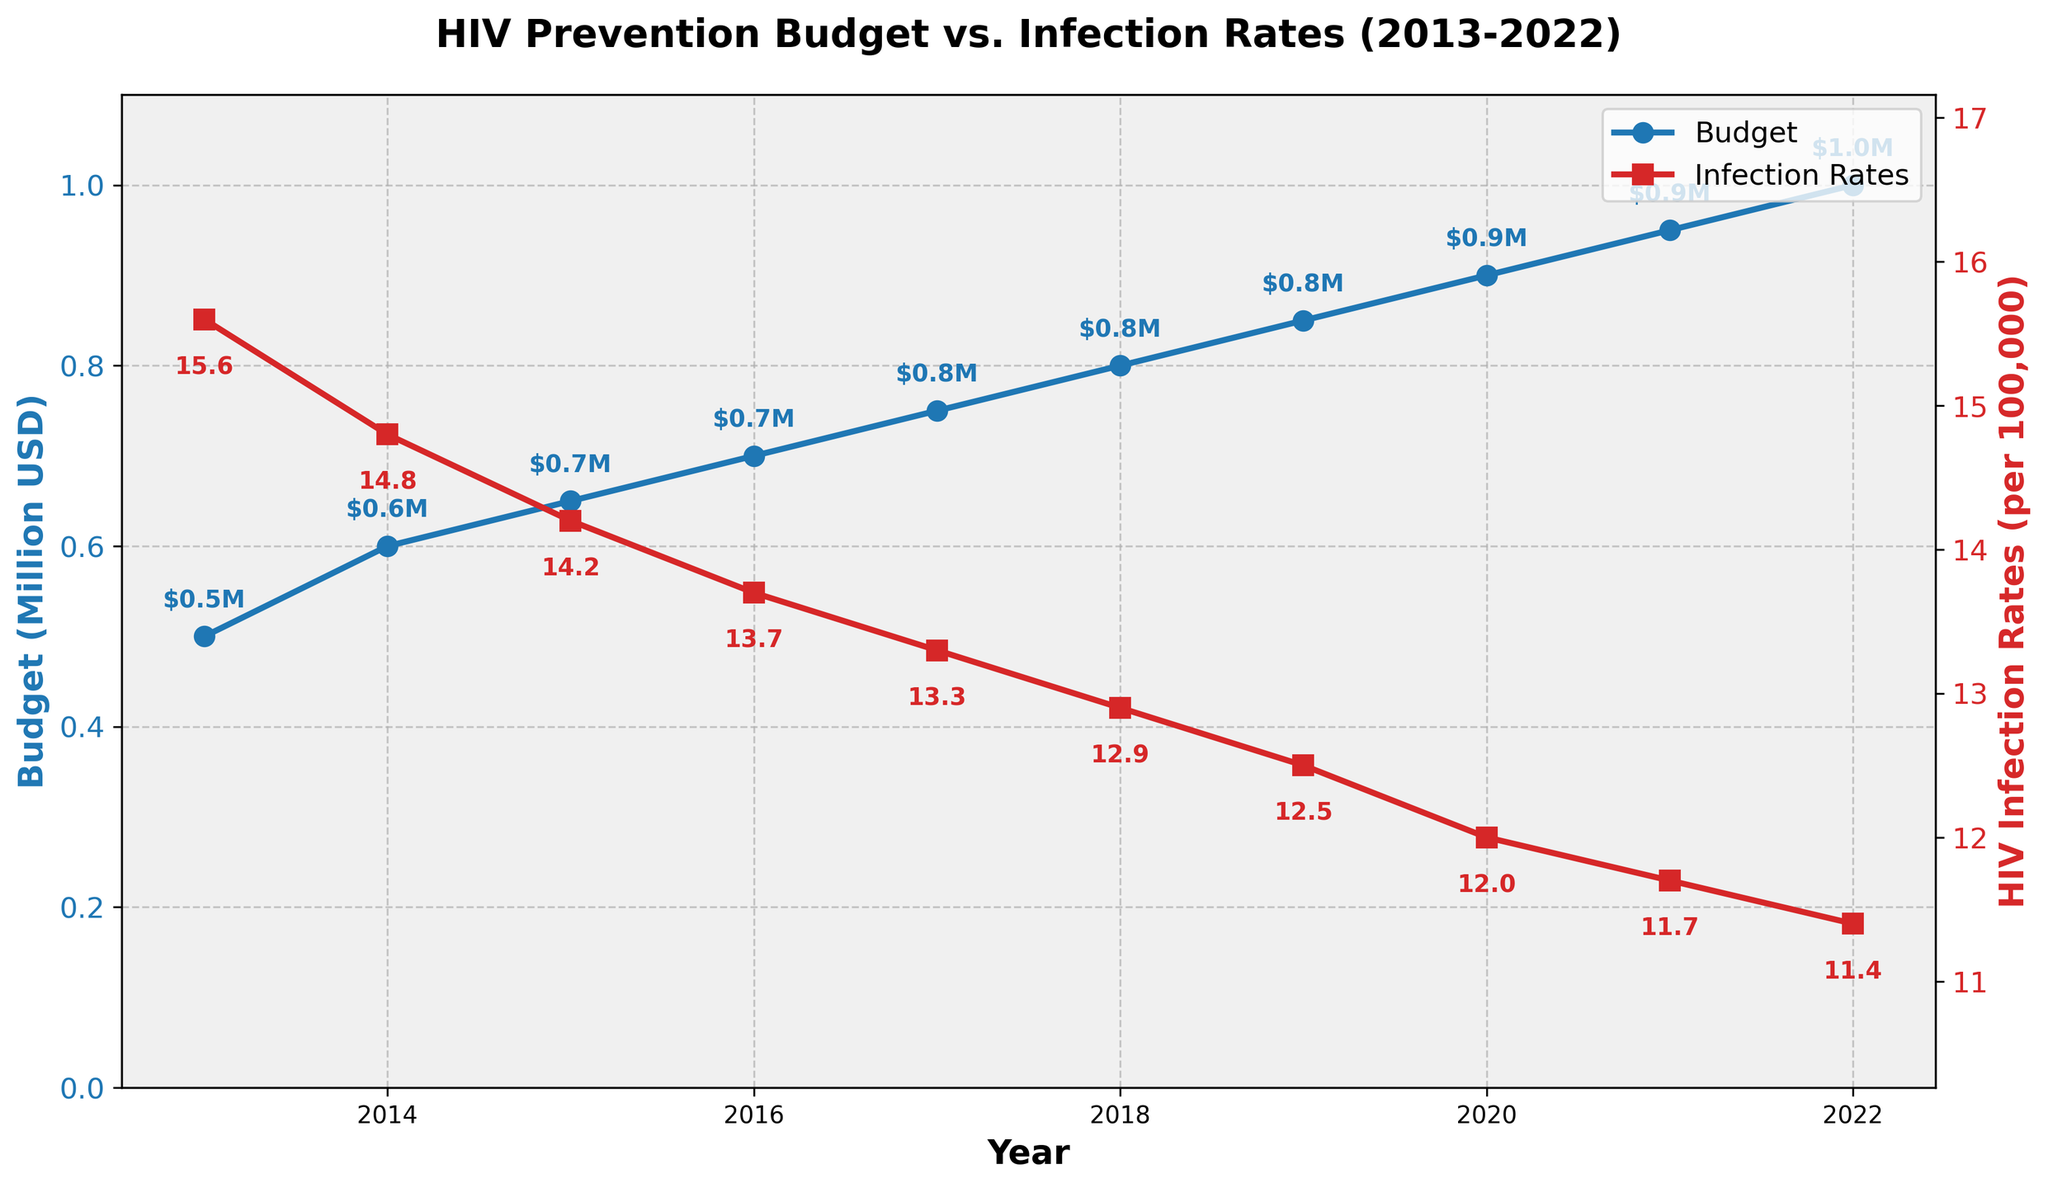What is the title of the figure? The title is displayed at the top of the figure in bold. It summarizes the content/subject of the plot.
Answer: HIV Prevention Budget vs. Infection Rates (2013-2022) What is the y-axis label on the left side of the figure? The y-axis label on the left indicates the unit of the plotted budget data and is written in bold.
Answer: Budget (Million USD) What trend do you observe in the budget allocated for HIV prevention programs from 2013 to 2022? By looking at the blue line with circular markers, you can see if the budget increases, decreases, or remains constant over the years. The budget shows an increasing trend.
Answer: Increasing trend By how much did the budget allocated for HIV prevention programs increase from 2015 to 2020? In 2015, the budget was $0.65 million, and in 2020, it was $0.9 million. Subtract the value in 2015 from that in 2020 to get the increase. 0.9M - 0.65M = 0.25M USD
Answer: 0.25M USD Which year had the highest HIV infection rate, and what was the rate? Identify the highest point on the red line with square markers, which represents the HIV infection rate, and note the corresponding year and rate.
Answer: 2013, 15.6 per 100,000 What correlation can be observed between the budget allocated and HIV infection rates over the years? Observing the plot, one can look for a pattern between the budgets in blue and the infection rates in red. As the budget increases, the infection rates show a decreasing trend.
Answer: Negative correlation What was the budget allocation and HIV infection rate in 2017? Identify the values from the graph where the year is 2017. The blue line shows the budget, and the red line shows the infection rate. Budget: $0.75M; Infection Rate: 13.3 per 100,000
Answer: Budget: $0.75M, Infection Rate: 13.3 per 100,000 Between which consecutive years did the largest decrease in HIV infection rates per 100,000 occur? Calculate the differences in infection rates from one year to the next and find the maximum decrease. Max decrease: 2013-2014, 15.6 - 14.8 = 0.8
Answer: Between 2013 and 2014 By what percentage did the HIV infection rate decrease from 2013 to 2022? Calculate the percentage decrease: ((Initial rate - Final rate) / Initial rate) * 100%. ((15.6 - 11.4) / 15.6) * 100% ≈ 26.92%
Answer: 26.92% What is the general relationship between the two plotted variables over the observed years? Observe the overall behavior of the two lines on the plot: as the budget increases, the infection rate generally decreases. This suggests an inverse relationship.
Answer: Inverse relationship 